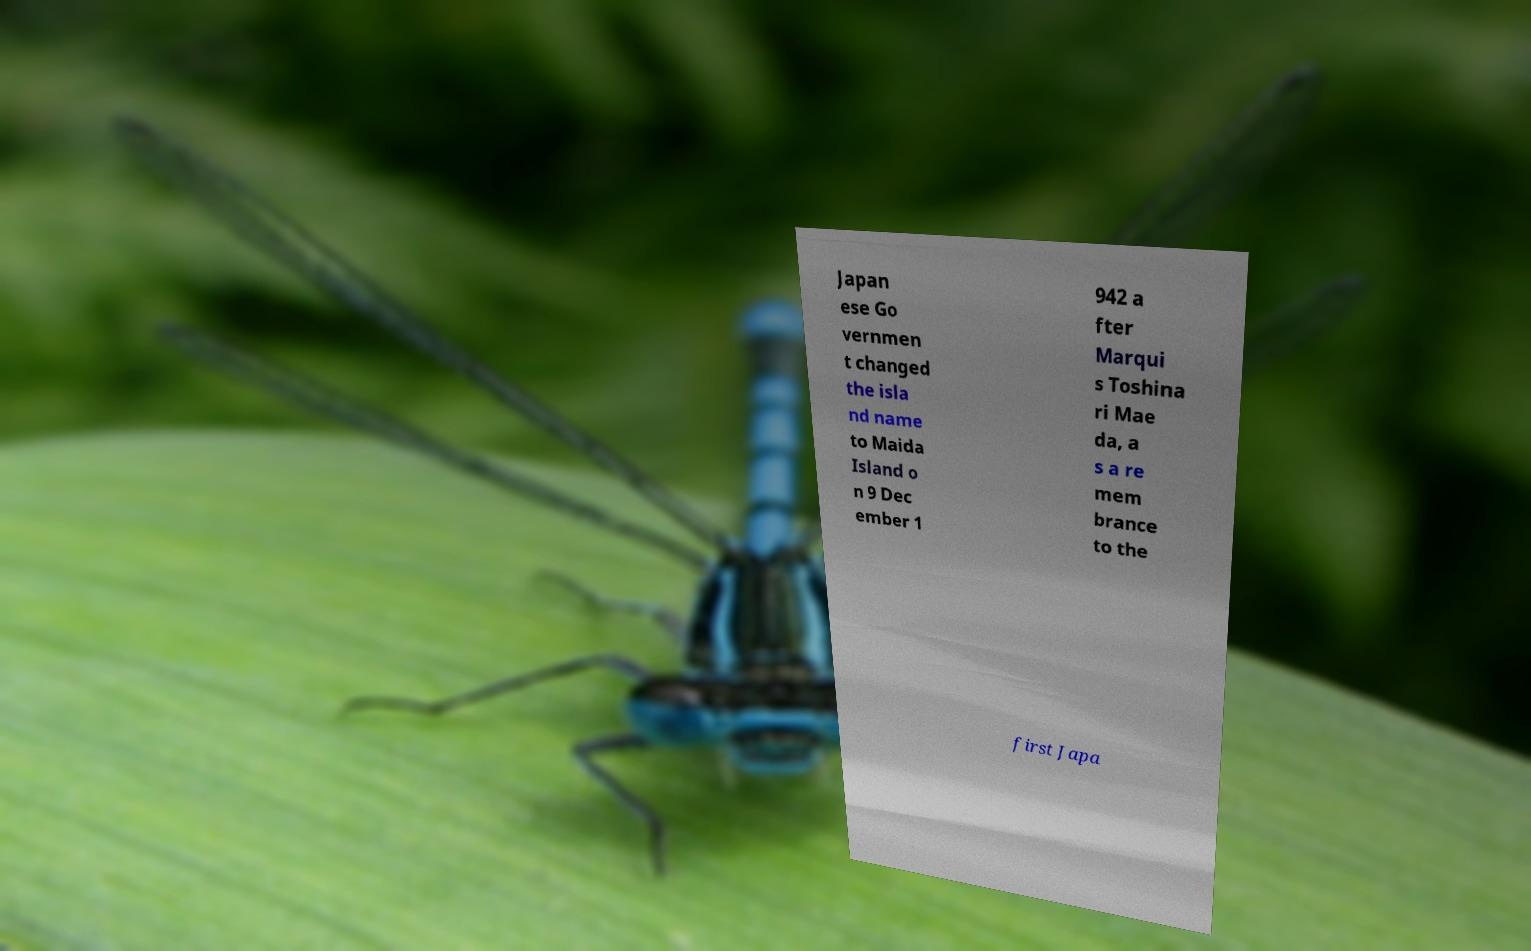Can you accurately transcribe the text from the provided image for me? Japan ese Go vernmen t changed the isla nd name to Maida Island o n 9 Dec ember 1 942 a fter Marqui s Toshina ri Mae da, a s a re mem brance to the first Japa 